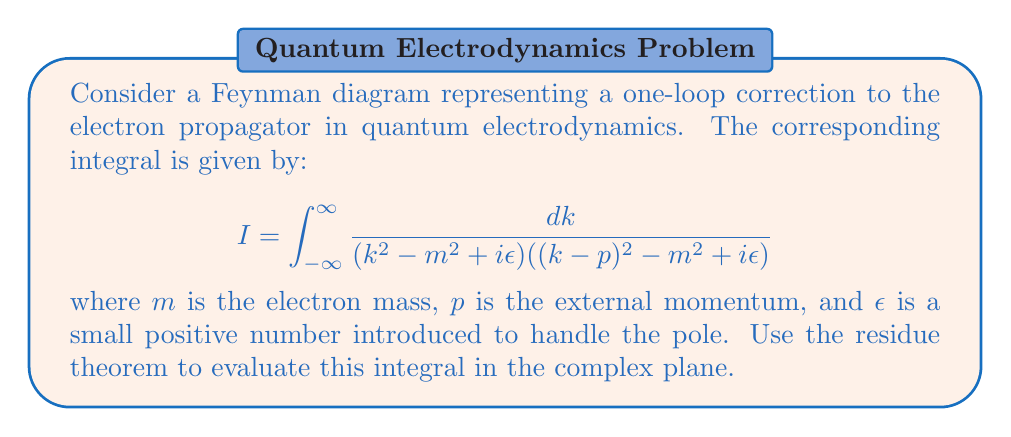Can you answer this question? 1) First, we need to identify the poles of the integrand. The denominator has two factors:
   $$(k^2 - m^2 + i\epsilon) = (k-\sqrt{m^2-i\epsilon})(k+\sqrt{m^2-i\epsilon})$$
   $$(k-p)^2 - m^2 + i\epsilon = ((k-p)-\sqrt{m^2-i\epsilon})((k-p)+\sqrt{m^2-i\epsilon})$$

2) The poles are at:
   $$k_1 = \sqrt{m^2-i\epsilon}, k_2 = -\sqrt{m^2-i\epsilon}, k_3 = p+\sqrt{m^2-i\epsilon}, k_4 = p-\sqrt{m^2-i\epsilon}$$

3) We can close the contour in the upper half-plane. The poles in the upper half-plane are $k_1$ and $k_3$.

4) Using the residue theorem:
   $$I = 2\pi i \sum \text{Res}(f, k_i)$$

5) Calculate the residues:
   $$\text{Res}(f, k_1) = \lim_{k \to k_1} \frac{k-k_1}{(k^2 - m^2 + i\epsilon)((k-p)^2 - m^2 + i\epsilon)}$$
   $$= \frac{1}{2k_1((k_1-p)^2 - m^2 + i\epsilon)}$$

   $$\text{Res}(f, k_3) = \lim_{k \to k_3} \frac{k-k_3}{(k^2 - m^2 + i\epsilon)((k-p)^2 - m^2 + i\epsilon)}$$
   $$= \frac{1}{(k_3^2 - m^2 + i\epsilon)(2(k_3-p))}$$

6) Sum the residues and multiply by $2\pi i$:
   $$I = 2\pi i \left(\frac{1}{2k_1((k_1-p)^2 - m^2 + i\epsilon)} + \frac{1}{(k_3^2 - m^2 + i\epsilon)(2(k_3-p))}\right)$$

7) Simplify by taking the limit $\epsilon \to 0$:
   $$I = \frac{\pi i}{m((p-m)^2 - m^2)} + \frac{\pi i}{m((p+m)^2 - m^2)}$$

8) Further simplification leads to:
   $$I = \frac{\pi i}{m(p^2-2mp)} + \frac{\pi i}{m(p^2+2mp)} = \frac{2\pi i}{m(p^2-4m^2)}$$
Answer: $\frac{2\pi i}{m(p^2-4m^2)}$ 